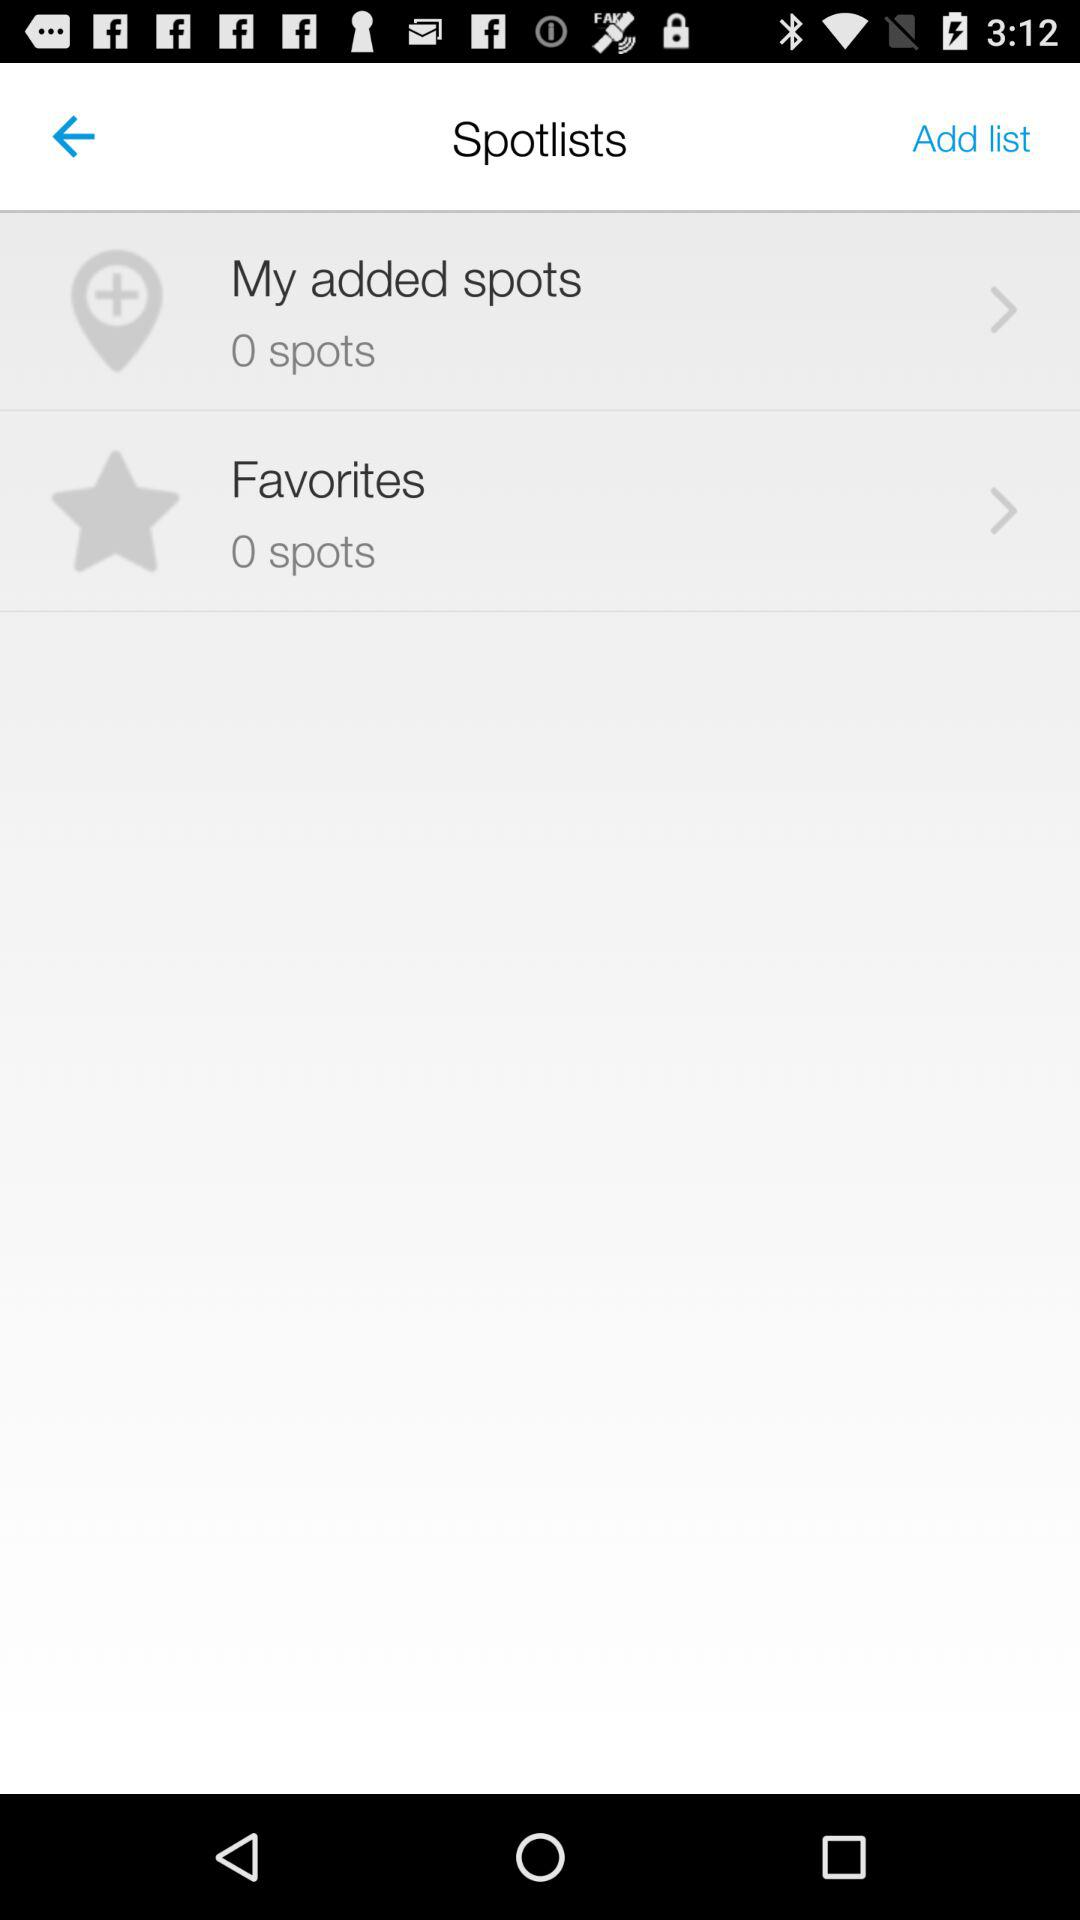What is the number of spots in "Favorites"? The number of spots in "Favorites" is 0. 